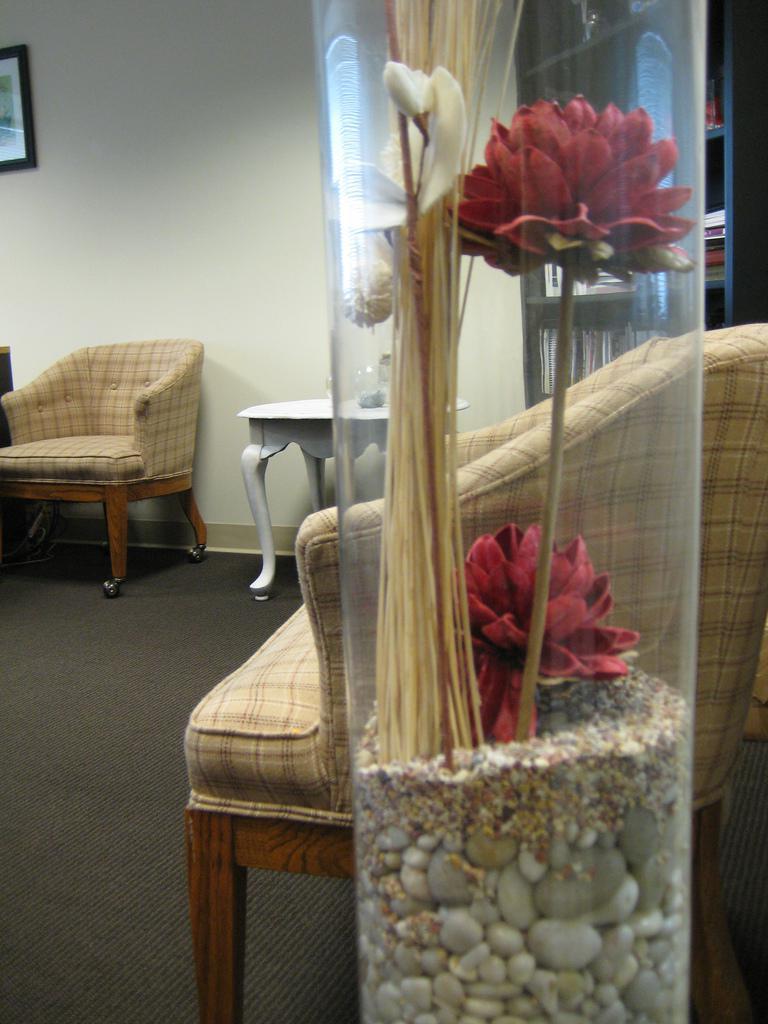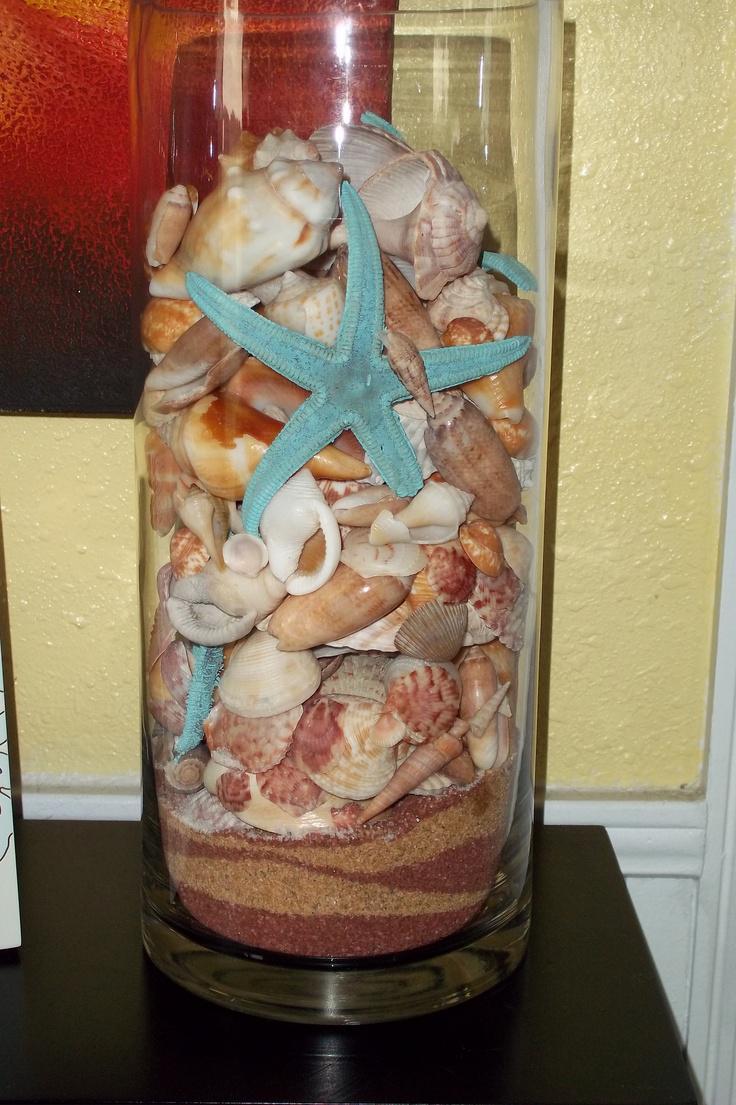The first image is the image on the left, the second image is the image on the right. Assess this claim about the two images: "There are flowers in a vase in the image on the left.". Correct or not? Answer yes or no. Yes. 